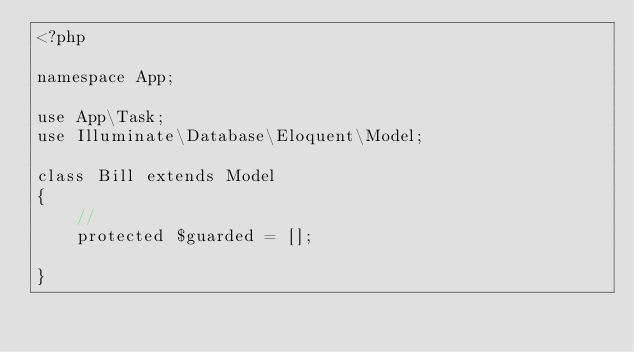<code> <loc_0><loc_0><loc_500><loc_500><_PHP_><?php

namespace App;

use App\Task;
use Illuminate\Database\Eloquent\Model;

class Bill extends Model
{
    //
    protected $guarded = [];

}
</code> 